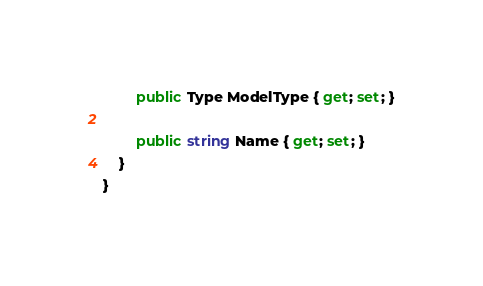<code> <loc_0><loc_0><loc_500><loc_500><_C#_>        public Type ModelType { get; set; }

        public string Name { get; set; }
    }
}</code> 